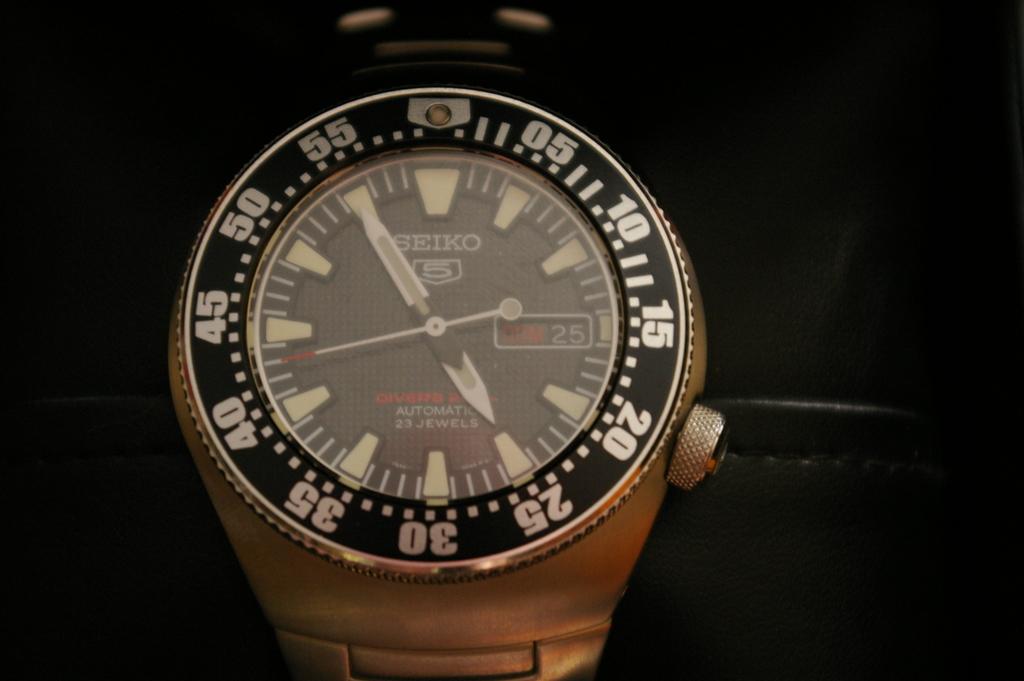What is the time of the watch?
Your answer should be compact. 5:55. What brand is this watch?
Provide a succinct answer. Seiko. 